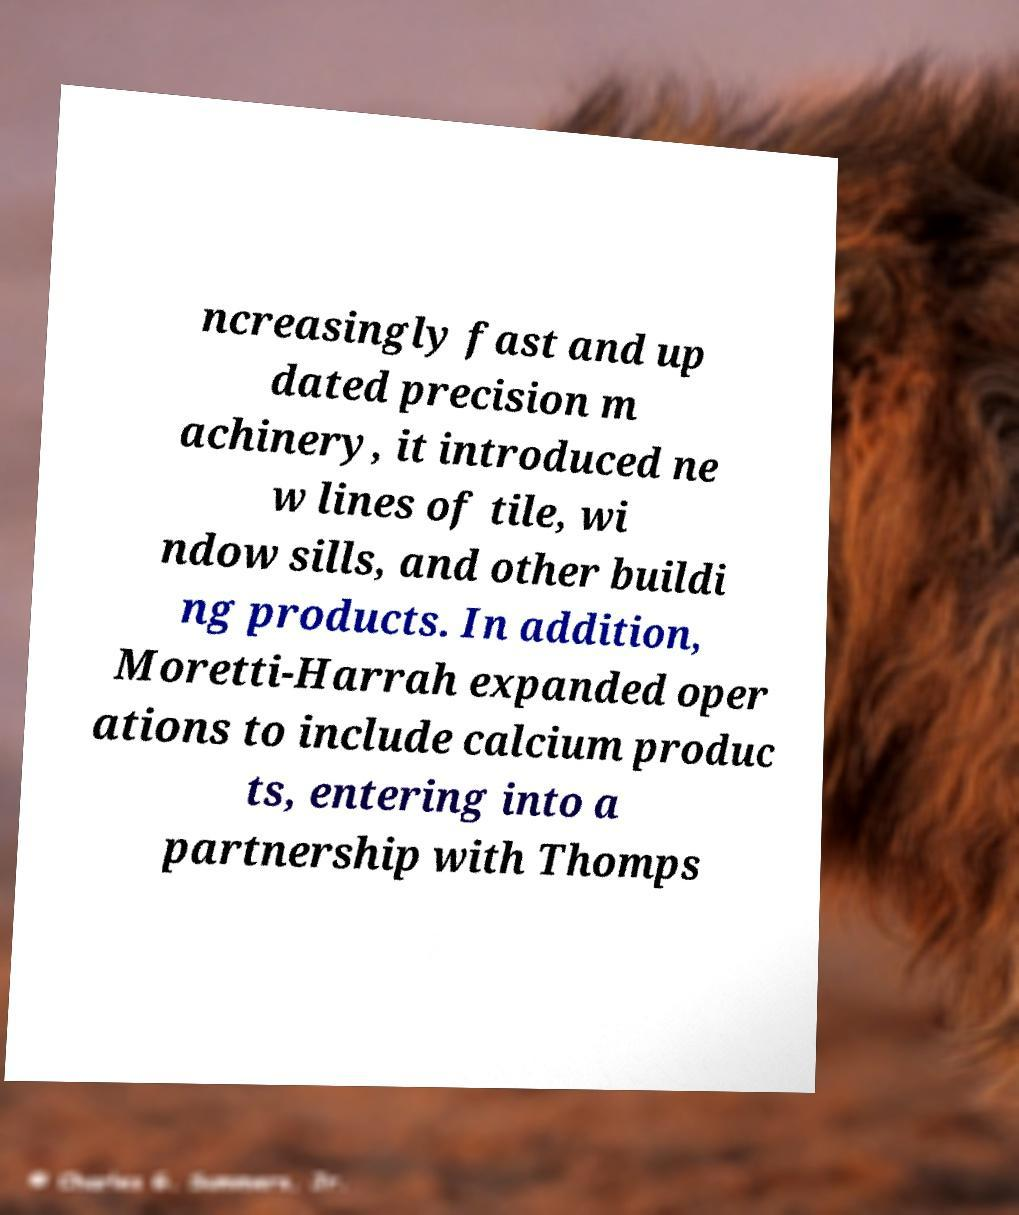Can you read and provide the text displayed in the image?This photo seems to have some interesting text. Can you extract and type it out for me? ncreasingly fast and up dated precision m achinery, it introduced ne w lines of tile, wi ndow sills, and other buildi ng products. In addition, Moretti-Harrah expanded oper ations to include calcium produc ts, entering into a partnership with Thomps 